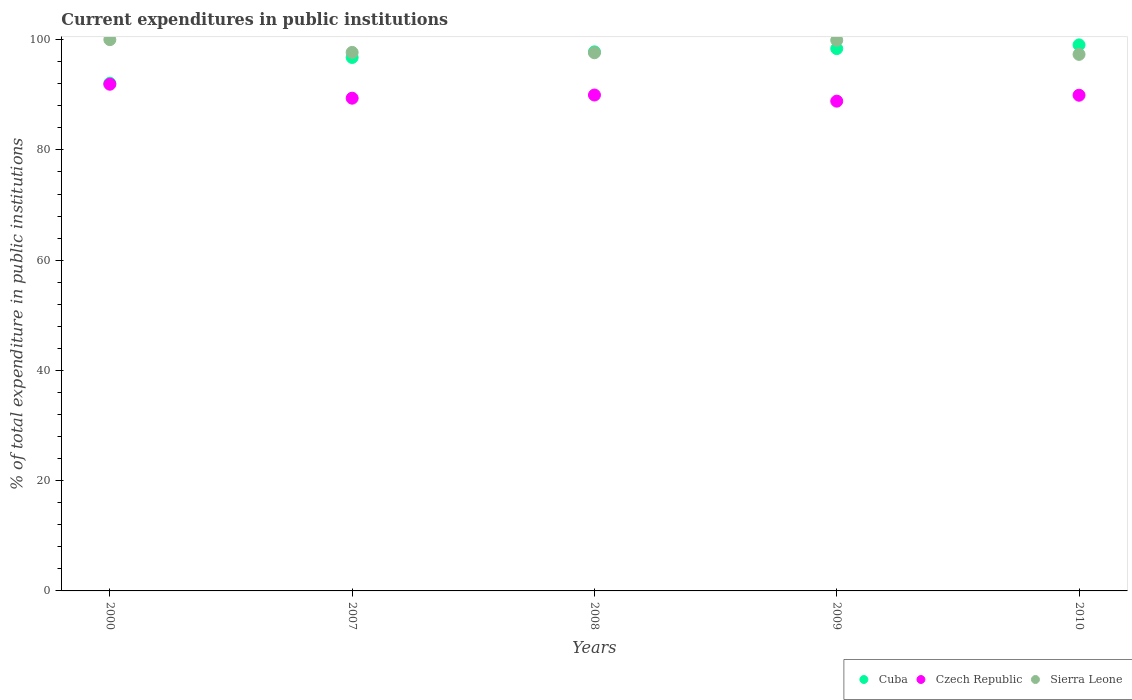How many different coloured dotlines are there?
Your response must be concise. 3. Is the number of dotlines equal to the number of legend labels?
Offer a terse response. Yes. What is the current expenditures in public institutions in Cuba in 2009?
Provide a short and direct response. 98.38. Across all years, what is the minimum current expenditures in public institutions in Sierra Leone?
Provide a short and direct response. 97.33. What is the total current expenditures in public institutions in Cuba in the graph?
Your answer should be compact. 484.07. What is the difference between the current expenditures in public institutions in Sierra Leone in 2000 and that in 2008?
Your answer should be compact. 2.38. What is the difference between the current expenditures in public institutions in Cuba in 2000 and the current expenditures in public institutions in Sierra Leone in 2007?
Provide a succinct answer. -5.6. What is the average current expenditures in public institutions in Cuba per year?
Your response must be concise. 96.81. In the year 2009, what is the difference between the current expenditures in public institutions in Czech Republic and current expenditures in public institutions in Cuba?
Offer a very short reply. -9.53. In how many years, is the current expenditures in public institutions in Sierra Leone greater than 16 %?
Your response must be concise. 5. What is the ratio of the current expenditures in public institutions in Czech Republic in 2000 to that in 2008?
Your answer should be compact. 1.02. Is the current expenditures in public institutions in Sierra Leone in 2007 less than that in 2008?
Make the answer very short. No. Is the difference between the current expenditures in public institutions in Czech Republic in 2000 and 2007 greater than the difference between the current expenditures in public institutions in Cuba in 2000 and 2007?
Give a very brief answer. Yes. What is the difference between the highest and the second highest current expenditures in public institutions in Cuba?
Offer a very short reply. 0.67. What is the difference between the highest and the lowest current expenditures in public institutions in Cuba?
Your answer should be compact. 6.96. In how many years, is the current expenditures in public institutions in Sierra Leone greater than the average current expenditures in public institutions in Sierra Leone taken over all years?
Offer a terse response. 2. Is the sum of the current expenditures in public institutions in Sierra Leone in 2007 and 2009 greater than the maximum current expenditures in public institutions in Czech Republic across all years?
Your answer should be very brief. Yes. Does the current expenditures in public institutions in Cuba monotonically increase over the years?
Provide a succinct answer. Yes. Is the current expenditures in public institutions in Cuba strictly greater than the current expenditures in public institutions in Czech Republic over the years?
Keep it short and to the point. Yes. How many years are there in the graph?
Provide a short and direct response. 5. What is the difference between two consecutive major ticks on the Y-axis?
Offer a terse response. 20. Does the graph contain grids?
Provide a succinct answer. No. Where does the legend appear in the graph?
Your answer should be very brief. Bottom right. How many legend labels are there?
Ensure brevity in your answer.  3. How are the legend labels stacked?
Make the answer very short. Horizontal. What is the title of the graph?
Offer a very short reply. Current expenditures in public institutions. What is the label or title of the X-axis?
Provide a succinct answer. Years. What is the label or title of the Y-axis?
Keep it short and to the point. % of total expenditure in public institutions. What is the % of total expenditure in public institutions of Cuba in 2000?
Offer a very short reply. 92.09. What is the % of total expenditure in public institutions in Czech Republic in 2000?
Offer a very short reply. 91.91. What is the % of total expenditure in public institutions in Sierra Leone in 2000?
Keep it short and to the point. 100. What is the % of total expenditure in public institutions of Cuba in 2007?
Keep it short and to the point. 96.77. What is the % of total expenditure in public institutions of Czech Republic in 2007?
Your answer should be very brief. 89.38. What is the % of total expenditure in public institutions of Sierra Leone in 2007?
Provide a short and direct response. 97.69. What is the % of total expenditure in public institutions of Cuba in 2008?
Keep it short and to the point. 97.78. What is the % of total expenditure in public institutions in Czech Republic in 2008?
Offer a terse response. 89.96. What is the % of total expenditure in public institutions in Sierra Leone in 2008?
Your answer should be very brief. 97.62. What is the % of total expenditure in public institutions in Cuba in 2009?
Provide a succinct answer. 98.38. What is the % of total expenditure in public institutions in Czech Republic in 2009?
Provide a succinct answer. 88.84. What is the % of total expenditure in public institutions of Sierra Leone in 2009?
Offer a very short reply. 99.89. What is the % of total expenditure in public institutions of Cuba in 2010?
Ensure brevity in your answer.  99.05. What is the % of total expenditure in public institutions of Czech Republic in 2010?
Your response must be concise. 89.92. What is the % of total expenditure in public institutions of Sierra Leone in 2010?
Give a very brief answer. 97.33. Across all years, what is the maximum % of total expenditure in public institutions in Cuba?
Your answer should be very brief. 99.05. Across all years, what is the maximum % of total expenditure in public institutions in Czech Republic?
Ensure brevity in your answer.  91.91. Across all years, what is the maximum % of total expenditure in public institutions of Sierra Leone?
Your response must be concise. 100. Across all years, what is the minimum % of total expenditure in public institutions of Cuba?
Keep it short and to the point. 92.09. Across all years, what is the minimum % of total expenditure in public institutions of Czech Republic?
Provide a short and direct response. 88.84. Across all years, what is the minimum % of total expenditure in public institutions in Sierra Leone?
Your answer should be compact. 97.33. What is the total % of total expenditure in public institutions of Cuba in the graph?
Provide a short and direct response. 484.07. What is the total % of total expenditure in public institutions in Czech Republic in the graph?
Make the answer very short. 450.01. What is the total % of total expenditure in public institutions in Sierra Leone in the graph?
Make the answer very short. 492.53. What is the difference between the % of total expenditure in public institutions of Cuba in 2000 and that in 2007?
Make the answer very short. -4.68. What is the difference between the % of total expenditure in public institutions of Czech Republic in 2000 and that in 2007?
Keep it short and to the point. 2.53. What is the difference between the % of total expenditure in public institutions in Sierra Leone in 2000 and that in 2007?
Keep it short and to the point. 2.31. What is the difference between the % of total expenditure in public institutions of Cuba in 2000 and that in 2008?
Provide a succinct answer. -5.69. What is the difference between the % of total expenditure in public institutions of Czech Republic in 2000 and that in 2008?
Make the answer very short. 1.96. What is the difference between the % of total expenditure in public institutions of Sierra Leone in 2000 and that in 2008?
Ensure brevity in your answer.  2.38. What is the difference between the % of total expenditure in public institutions of Cuba in 2000 and that in 2009?
Ensure brevity in your answer.  -6.29. What is the difference between the % of total expenditure in public institutions of Czech Republic in 2000 and that in 2009?
Provide a short and direct response. 3.07. What is the difference between the % of total expenditure in public institutions of Sierra Leone in 2000 and that in 2009?
Your answer should be very brief. 0.11. What is the difference between the % of total expenditure in public institutions in Cuba in 2000 and that in 2010?
Provide a short and direct response. -6.96. What is the difference between the % of total expenditure in public institutions in Czech Republic in 2000 and that in 2010?
Your response must be concise. 2. What is the difference between the % of total expenditure in public institutions in Sierra Leone in 2000 and that in 2010?
Offer a terse response. 2.67. What is the difference between the % of total expenditure in public institutions of Cuba in 2007 and that in 2008?
Your answer should be very brief. -1.01. What is the difference between the % of total expenditure in public institutions of Czech Republic in 2007 and that in 2008?
Offer a very short reply. -0.57. What is the difference between the % of total expenditure in public institutions in Sierra Leone in 2007 and that in 2008?
Make the answer very short. 0.06. What is the difference between the % of total expenditure in public institutions in Cuba in 2007 and that in 2009?
Make the answer very short. -1.61. What is the difference between the % of total expenditure in public institutions in Czech Republic in 2007 and that in 2009?
Ensure brevity in your answer.  0.54. What is the difference between the % of total expenditure in public institutions in Sierra Leone in 2007 and that in 2009?
Your answer should be compact. -2.2. What is the difference between the % of total expenditure in public institutions in Cuba in 2007 and that in 2010?
Keep it short and to the point. -2.28. What is the difference between the % of total expenditure in public institutions of Czech Republic in 2007 and that in 2010?
Keep it short and to the point. -0.54. What is the difference between the % of total expenditure in public institutions in Sierra Leone in 2007 and that in 2010?
Provide a short and direct response. 0.36. What is the difference between the % of total expenditure in public institutions of Cuba in 2008 and that in 2009?
Your answer should be very brief. -0.59. What is the difference between the % of total expenditure in public institutions of Czech Republic in 2008 and that in 2009?
Make the answer very short. 1.11. What is the difference between the % of total expenditure in public institutions in Sierra Leone in 2008 and that in 2009?
Ensure brevity in your answer.  -2.26. What is the difference between the % of total expenditure in public institutions of Cuba in 2008 and that in 2010?
Keep it short and to the point. -1.26. What is the difference between the % of total expenditure in public institutions in Czech Republic in 2008 and that in 2010?
Provide a short and direct response. 0.04. What is the difference between the % of total expenditure in public institutions of Sierra Leone in 2008 and that in 2010?
Offer a terse response. 0.3. What is the difference between the % of total expenditure in public institutions of Cuba in 2009 and that in 2010?
Your answer should be compact. -0.67. What is the difference between the % of total expenditure in public institutions in Czech Republic in 2009 and that in 2010?
Make the answer very short. -1.07. What is the difference between the % of total expenditure in public institutions of Sierra Leone in 2009 and that in 2010?
Offer a very short reply. 2.56. What is the difference between the % of total expenditure in public institutions in Cuba in 2000 and the % of total expenditure in public institutions in Czech Republic in 2007?
Give a very brief answer. 2.71. What is the difference between the % of total expenditure in public institutions in Cuba in 2000 and the % of total expenditure in public institutions in Sierra Leone in 2007?
Make the answer very short. -5.6. What is the difference between the % of total expenditure in public institutions in Czech Republic in 2000 and the % of total expenditure in public institutions in Sierra Leone in 2007?
Provide a succinct answer. -5.78. What is the difference between the % of total expenditure in public institutions in Cuba in 2000 and the % of total expenditure in public institutions in Czech Republic in 2008?
Keep it short and to the point. 2.14. What is the difference between the % of total expenditure in public institutions of Cuba in 2000 and the % of total expenditure in public institutions of Sierra Leone in 2008?
Provide a short and direct response. -5.53. What is the difference between the % of total expenditure in public institutions in Czech Republic in 2000 and the % of total expenditure in public institutions in Sierra Leone in 2008?
Your answer should be very brief. -5.71. What is the difference between the % of total expenditure in public institutions in Cuba in 2000 and the % of total expenditure in public institutions in Czech Republic in 2009?
Give a very brief answer. 3.25. What is the difference between the % of total expenditure in public institutions of Cuba in 2000 and the % of total expenditure in public institutions of Sierra Leone in 2009?
Offer a very short reply. -7.8. What is the difference between the % of total expenditure in public institutions of Czech Republic in 2000 and the % of total expenditure in public institutions of Sierra Leone in 2009?
Ensure brevity in your answer.  -7.98. What is the difference between the % of total expenditure in public institutions of Cuba in 2000 and the % of total expenditure in public institutions of Czech Republic in 2010?
Your answer should be compact. 2.17. What is the difference between the % of total expenditure in public institutions of Cuba in 2000 and the % of total expenditure in public institutions of Sierra Leone in 2010?
Provide a short and direct response. -5.24. What is the difference between the % of total expenditure in public institutions in Czech Republic in 2000 and the % of total expenditure in public institutions in Sierra Leone in 2010?
Offer a terse response. -5.41. What is the difference between the % of total expenditure in public institutions in Cuba in 2007 and the % of total expenditure in public institutions in Czech Republic in 2008?
Offer a terse response. 6.81. What is the difference between the % of total expenditure in public institutions of Cuba in 2007 and the % of total expenditure in public institutions of Sierra Leone in 2008?
Offer a terse response. -0.86. What is the difference between the % of total expenditure in public institutions in Czech Republic in 2007 and the % of total expenditure in public institutions in Sierra Leone in 2008?
Your answer should be compact. -8.24. What is the difference between the % of total expenditure in public institutions in Cuba in 2007 and the % of total expenditure in public institutions in Czech Republic in 2009?
Offer a very short reply. 7.93. What is the difference between the % of total expenditure in public institutions in Cuba in 2007 and the % of total expenditure in public institutions in Sierra Leone in 2009?
Keep it short and to the point. -3.12. What is the difference between the % of total expenditure in public institutions in Czech Republic in 2007 and the % of total expenditure in public institutions in Sierra Leone in 2009?
Provide a short and direct response. -10.51. What is the difference between the % of total expenditure in public institutions in Cuba in 2007 and the % of total expenditure in public institutions in Czech Republic in 2010?
Your answer should be very brief. 6.85. What is the difference between the % of total expenditure in public institutions of Cuba in 2007 and the % of total expenditure in public institutions of Sierra Leone in 2010?
Keep it short and to the point. -0.56. What is the difference between the % of total expenditure in public institutions in Czech Republic in 2007 and the % of total expenditure in public institutions in Sierra Leone in 2010?
Your answer should be very brief. -7.95. What is the difference between the % of total expenditure in public institutions in Cuba in 2008 and the % of total expenditure in public institutions in Czech Republic in 2009?
Your response must be concise. 8.94. What is the difference between the % of total expenditure in public institutions of Cuba in 2008 and the % of total expenditure in public institutions of Sierra Leone in 2009?
Your response must be concise. -2.11. What is the difference between the % of total expenditure in public institutions of Czech Republic in 2008 and the % of total expenditure in public institutions of Sierra Leone in 2009?
Offer a terse response. -9.93. What is the difference between the % of total expenditure in public institutions of Cuba in 2008 and the % of total expenditure in public institutions of Czech Republic in 2010?
Offer a very short reply. 7.87. What is the difference between the % of total expenditure in public institutions of Cuba in 2008 and the % of total expenditure in public institutions of Sierra Leone in 2010?
Ensure brevity in your answer.  0.46. What is the difference between the % of total expenditure in public institutions in Czech Republic in 2008 and the % of total expenditure in public institutions in Sierra Leone in 2010?
Your answer should be very brief. -7.37. What is the difference between the % of total expenditure in public institutions in Cuba in 2009 and the % of total expenditure in public institutions in Czech Republic in 2010?
Keep it short and to the point. 8.46. What is the difference between the % of total expenditure in public institutions in Cuba in 2009 and the % of total expenditure in public institutions in Sierra Leone in 2010?
Your response must be concise. 1.05. What is the difference between the % of total expenditure in public institutions in Czech Republic in 2009 and the % of total expenditure in public institutions in Sierra Leone in 2010?
Ensure brevity in your answer.  -8.48. What is the average % of total expenditure in public institutions in Cuba per year?
Your answer should be compact. 96.81. What is the average % of total expenditure in public institutions of Czech Republic per year?
Offer a very short reply. 90. What is the average % of total expenditure in public institutions of Sierra Leone per year?
Provide a succinct answer. 98.51. In the year 2000, what is the difference between the % of total expenditure in public institutions of Cuba and % of total expenditure in public institutions of Czech Republic?
Keep it short and to the point. 0.18. In the year 2000, what is the difference between the % of total expenditure in public institutions of Cuba and % of total expenditure in public institutions of Sierra Leone?
Offer a terse response. -7.91. In the year 2000, what is the difference between the % of total expenditure in public institutions in Czech Republic and % of total expenditure in public institutions in Sierra Leone?
Ensure brevity in your answer.  -8.09. In the year 2007, what is the difference between the % of total expenditure in public institutions of Cuba and % of total expenditure in public institutions of Czech Republic?
Your response must be concise. 7.39. In the year 2007, what is the difference between the % of total expenditure in public institutions of Cuba and % of total expenditure in public institutions of Sierra Leone?
Your answer should be compact. -0.92. In the year 2007, what is the difference between the % of total expenditure in public institutions of Czech Republic and % of total expenditure in public institutions of Sierra Leone?
Offer a very short reply. -8.31. In the year 2008, what is the difference between the % of total expenditure in public institutions of Cuba and % of total expenditure in public institutions of Czech Republic?
Make the answer very short. 7.83. In the year 2008, what is the difference between the % of total expenditure in public institutions in Cuba and % of total expenditure in public institutions in Sierra Leone?
Offer a very short reply. 0.16. In the year 2008, what is the difference between the % of total expenditure in public institutions of Czech Republic and % of total expenditure in public institutions of Sierra Leone?
Your answer should be compact. -7.67. In the year 2009, what is the difference between the % of total expenditure in public institutions of Cuba and % of total expenditure in public institutions of Czech Republic?
Give a very brief answer. 9.53. In the year 2009, what is the difference between the % of total expenditure in public institutions in Cuba and % of total expenditure in public institutions in Sierra Leone?
Give a very brief answer. -1.51. In the year 2009, what is the difference between the % of total expenditure in public institutions in Czech Republic and % of total expenditure in public institutions in Sierra Leone?
Your answer should be compact. -11.05. In the year 2010, what is the difference between the % of total expenditure in public institutions in Cuba and % of total expenditure in public institutions in Czech Republic?
Your response must be concise. 9.13. In the year 2010, what is the difference between the % of total expenditure in public institutions in Cuba and % of total expenditure in public institutions in Sierra Leone?
Give a very brief answer. 1.72. In the year 2010, what is the difference between the % of total expenditure in public institutions of Czech Republic and % of total expenditure in public institutions of Sierra Leone?
Ensure brevity in your answer.  -7.41. What is the ratio of the % of total expenditure in public institutions of Cuba in 2000 to that in 2007?
Your response must be concise. 0.95. What is the ratio of the % of total expenditure in public institutions in Czech Republic in 2000 to that in 2007?
Offer a very short reply. 1.03. What is the ratio of the % of total expenditure in public institutions in Sierra Leone in 2000 to that in 2007?
Ensure brevity in your answer.  1.02. What is the ratio of the % of total expenditure in public institutions in Cuba in 2000 to that in 2008?
Ensure brevity in your answer.  0.94. What is the ratio of the % of total expenditure in public institutions of Czech Republic in 2000 to that in 2008?
Provide a short and direct response. 1.02. What is the ratio of the % of total expenditure in public institutions in Sierra Leone in 2000 to that in 2008?
Give a very brief answer. 1.02. What is the ratio of the % of total expenditure in public institutions of Cuba in 2000 to that in 2009?
Your response must be concise. 0.94. What is the ratio of the % of total expenditure in public institutions in Czech Republic in 2000 to that in 2009?
Provide a succinct answer. 1.03. What is the ratio of the % of total expenditure in public institutions of Sierra Leone in 2000 to that in 2009?
Make the answer very short. 1. What is the ratio of the % of total expenditure in public institutions in Cuba in 2000 to that in 2010?
Offer a very short reply. 0.93. What is the ratio of the % of total expenditure in public institutions of Czech Republic in 2000 to that in 2010?
Make the answer very short. 1.02. What is the ratio of the % of total expenditure in public institutions in Sierra Leone in 2000 to that in 2010?
Your answer should be compact. 1.03. What is the ratio of the % of total expenditure in public institutions of Cuba in 2007 to that in 2008?
Make the answer very short. 0.99. What is the ratio of the % of total expenditure in public institutions in Sierra Leone in 2007 to that in 2008?
Your answer should be compact. 1. What is the ratio of the % of total expenditure in public institutions in Cuba in 2007 to that in 2009?
Your answer should be compact. 0.98. What is the ratio of the % of total expenditure in public institutions in Cuba in 2007 to that in 2010?
Provide a short and direct response. 0.98. What is the ratio of the % of total expenditure in public institutions in Cuba in 2008 to that in 2009?
Offer a terse response. 0.99. What is the ratio of the % of total expenditure in public institutions of Czech Republic in 2008 to that in 2009?
Provide a succinct answer. 1.01. What is the ratio of the % of total expenditure in public institutions of Sierra Leone in 2008 to that in 2009?
Provide a short and direct response. 0.98. What is the ratio of the % of total expenditure in public institutions in Cuba in 2008 to that in 2010?
Provide a succinct answer. 0.99. What is the ratio of the % of total expenditure in public institutions of Sierra Leone in 2008 to that in 2010?
Make the answer very short. 1. What is the ratio of the % of total expenditure in public institutions of Cuba in 2009 to that in 2010?
Your answer should be compact. 0.99. What is the ratio of the % of total expenditure in public institutions of Sierra Leone in 2009 to that in 2010?
Give a very brief answer. 1.03. What is the difference between the highest and the second highest % of total expenditure in public institutions of Cuba?
Offer a terse response. 0.67. What is the difference between the highest and the second highest % of total expenditure in public institutions of Czech Republic?
Provide a short and direct response. 1.96. What is the difference between the highest and the second highest % of total expenditure in public institutions of Sierra Leone?
Ensure brevity in your answer.  0.11. What is the difference between the highest and the lowest % of total expenditure in public institutions in Cuba?
Make the answer very short. 6.96. What is the difference between the highest and the lowest % of total expenditure in public institutions of Czech Republic?
Ensure brevity in your answer.  3.07. What is the difference between the highest and the lowest % of total expenditure in public institutions of Sierra Leone?
Provide a succinct answer. 2.67. 